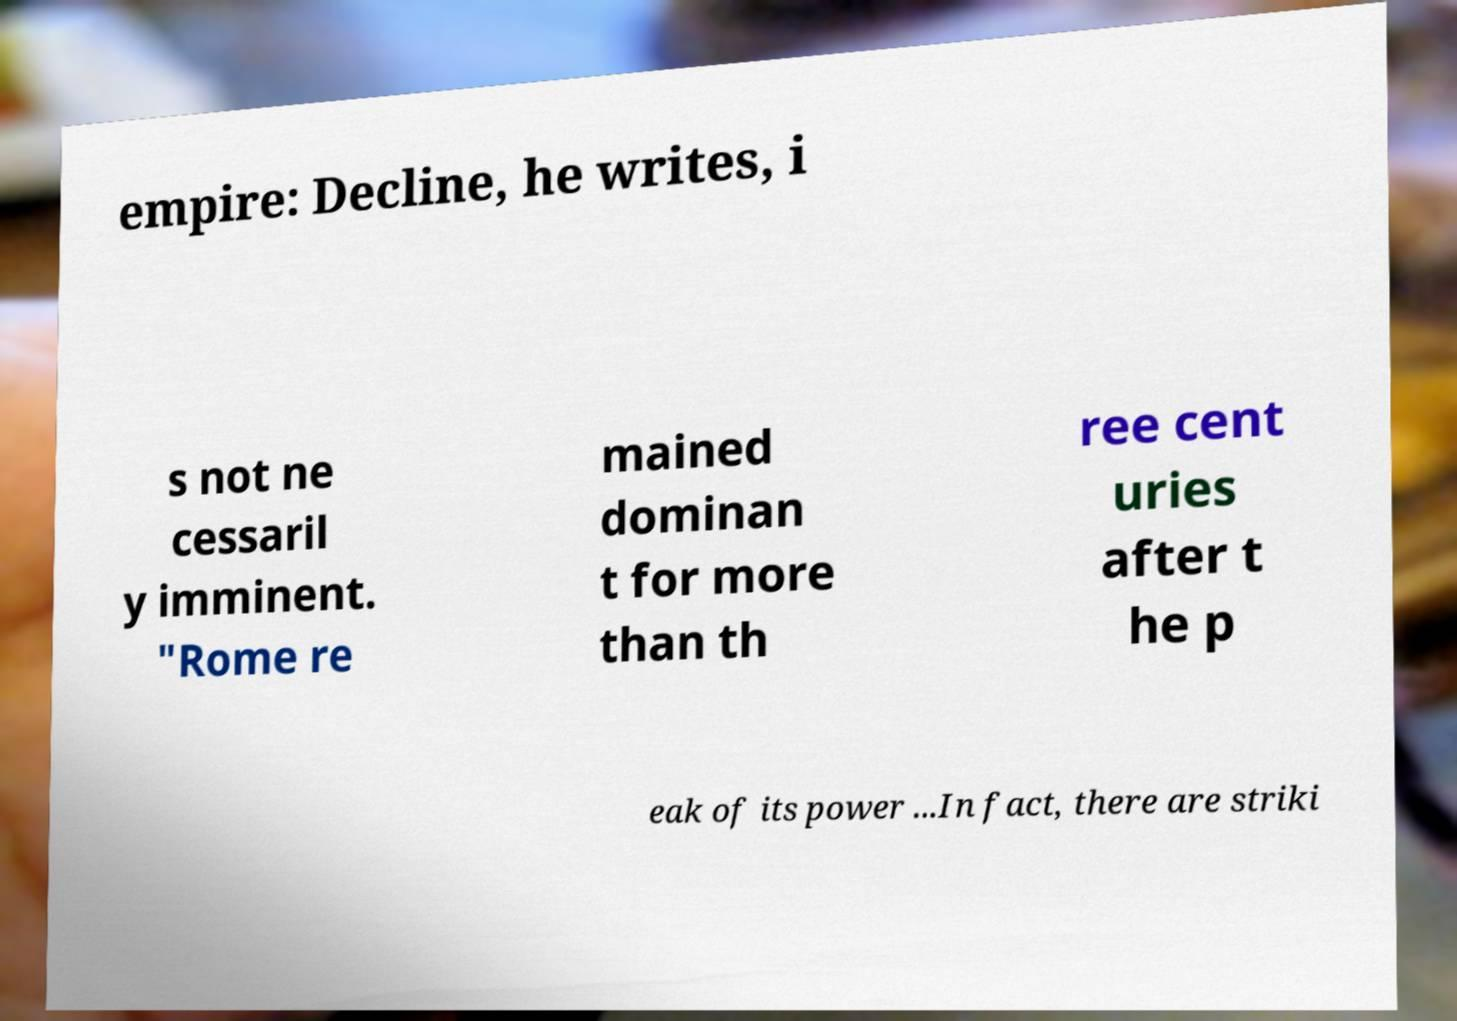Please identify and transcribe the text found in this image. empire: Decline, he writes, i s not ne cessaril y imminent. "Rome re mained dominan t for more than th ree cent uries after t he p eak of its power ...In fact, there are striki 